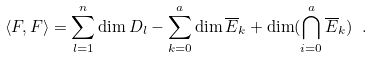Convert formula to latex. <formula><loc_0><loc_0><loc_500><loc_500>\langle F , F \rangle = \sum _ { l = 1 } ^ { n } \dim D _ { l } - \sum _ { k = 0 } ^ { a } \dim \overline { E } _ { k } + \dim ( \bigcap _ { i = 0 } ^ { a } \overline { E } _ { k } ) \ .</formula> 